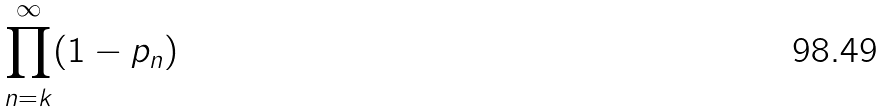<formula> <loc_0><loc_0><loc_500><loc_500>\prod _ { n = k } ^ { \infty } ( 1 - p _ { n } )</formula> 